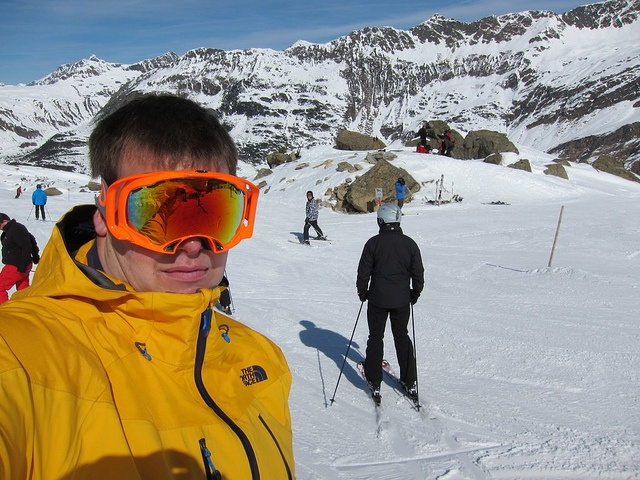Describe the objects in this image and their specific colors. I can see people in blue, orange, olive, and black tones, people in blue, black, lightgray, and darkgray tones, people in blue, black, brown, and maroon tones, skis in blue, darkgray, black, and gray tones, and people in blue, black, gray, and darkgray tones in this image. 